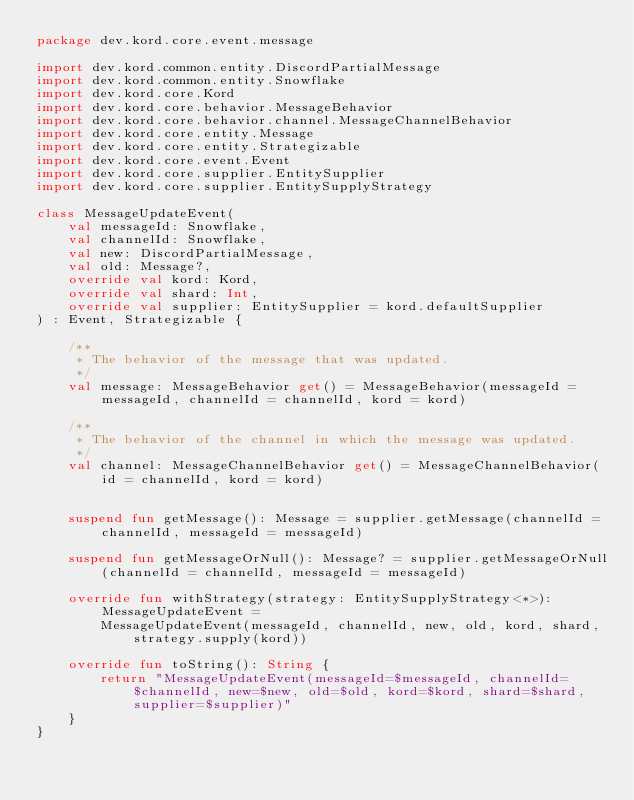Convert code to text. <code><loc_0><loc_0><loc_500><loc_500><_Kotlin_>package dev.kord.core.event.message

import dev.kord.common.entity.DiscordPartialMessage
import dev.kord.common.entity.Snowflake
import dev.kord.core.Kord
import dev.kord.core.behavior.MessageBehavior
import dev.kord.core.behavior.channel.MessageChannelBehavior
import dev.kord.core.entity.Message
import dev.kord.core.entity.Strategizable
import dev.kord.core.event.Event
import dev.kord.core.supplier.EntitySupplier
import dev.kord.core.supplier.EntitySupplyStrategy

class MessageUpdateEvent(
    val messageId: Snowflake,
    val channelId: Snowflake,
    val new: DiscordPartialMessage,
    val old: Message?,
    override val kord: Kord,
    override val shard: Int,
    override val supplier: EntitySupplier = kord.defaultSupplier
) : Event, Strategizable {

    /**
     * The behavior of the message that was updated.
     */
    val message: MessageBehavior get() = MessageBehavior(messageId = messageId, channelId = channelId, kord = kord)

    /**
     * The behavior of the channel in which the message was updated.
     */
    val channel: MessageChannelBehavior get() = MessageChannelBehavior(id = channelId, kord = kord)


    suspend fun getMessage(): Message = supplier.getMessage(channelId = channelId, messageId = messageId)

    suspend fun getMessageOrNull(): Message? = supplier.getMessageOrNull(channelId = channelId, messageId = messageId)

    override fun withStrategy(strategy: EntitySupplyStrategy<*>): MessageUpdateEvent =
        MessageUpdateEvent(messageId, channelId, new, old, kord, shard, strategy.supply(kord))

    override fun toString(): String {
        return "MessageUpdateEvent(messageId=$messageId, channelId=$channelId, new=$new, old=$old, kord=$kord, shard=$shard, supplier=$supplier)"
    }
}
</code> 